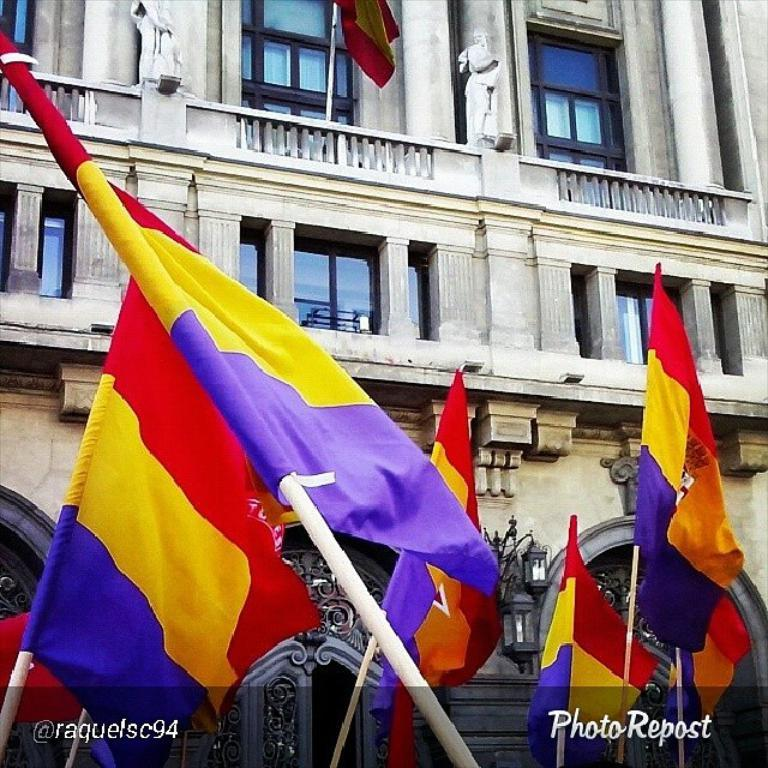What type of structure is visible in the image? There is a building in the image. What are some features of the building? The building has many windows and doors. Are there any decorations or symbols in front of the building? Yes, there are flags attached to poles in front of the building. What colors can be seen on the flags? The flags have red, yellow, and purple colors. Can you see a maid cleaning the windows of the building in the image? There is no maid present in the image, nor is there any indication of cleaning activities. 